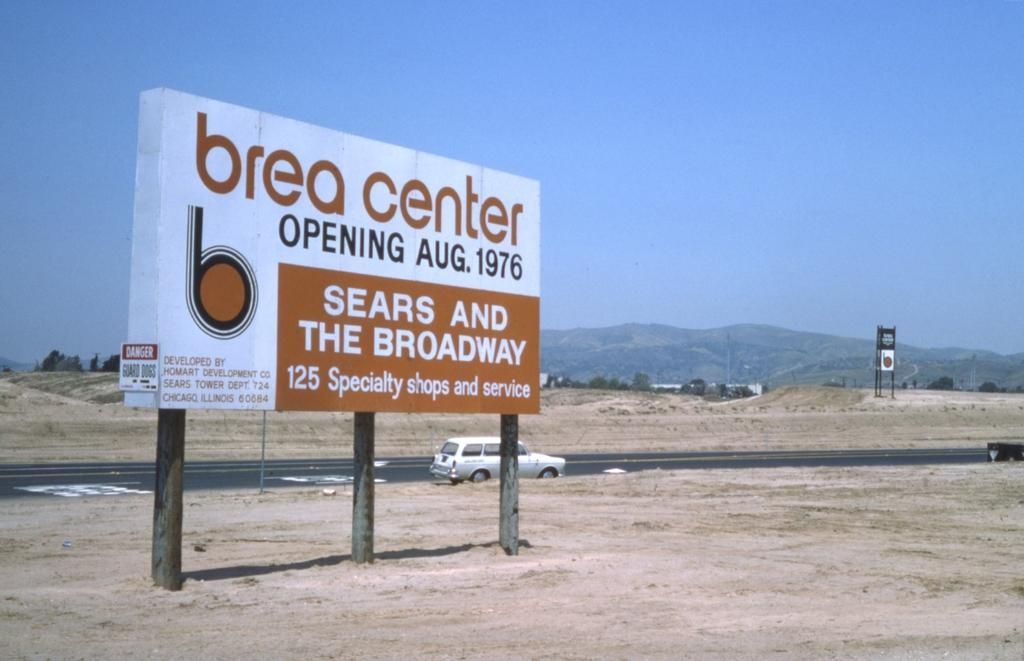<image>
Write a terse but informative summary of the picture. a brea center sign that is on the sand 